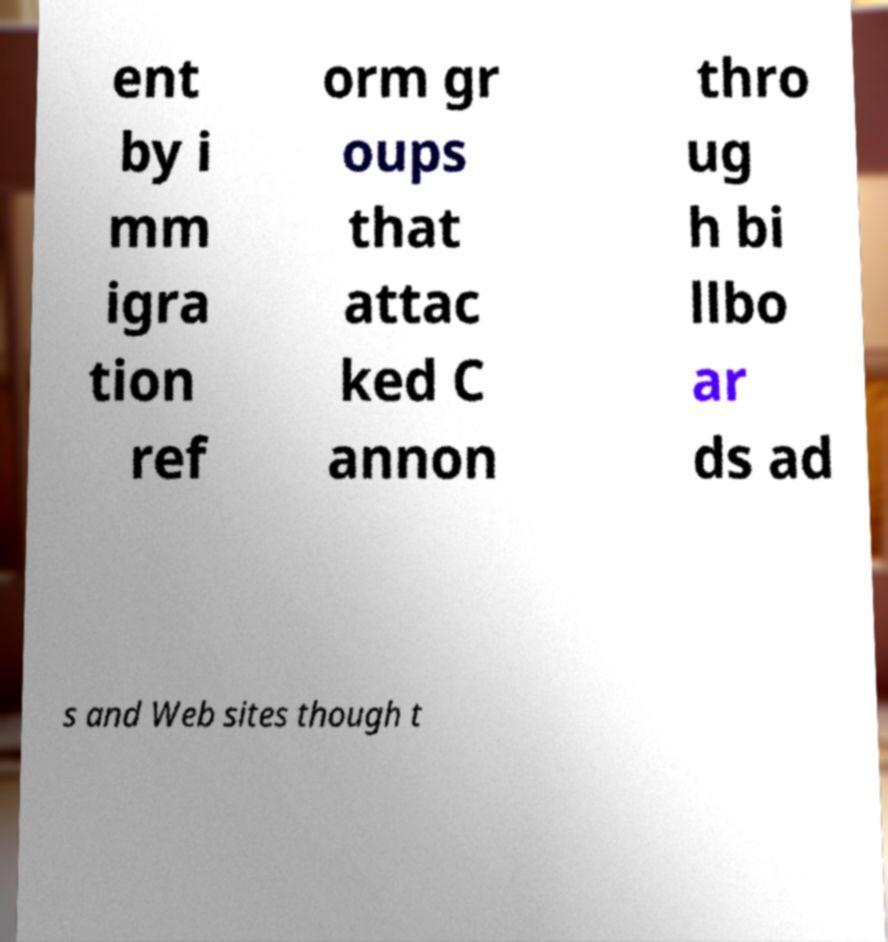Could you extract and type out the text from this image? ent by i mm igra tion ref orm gr oups that attac ked C annon thro ug h bi llbo ar ds ad s and Web sites though t 